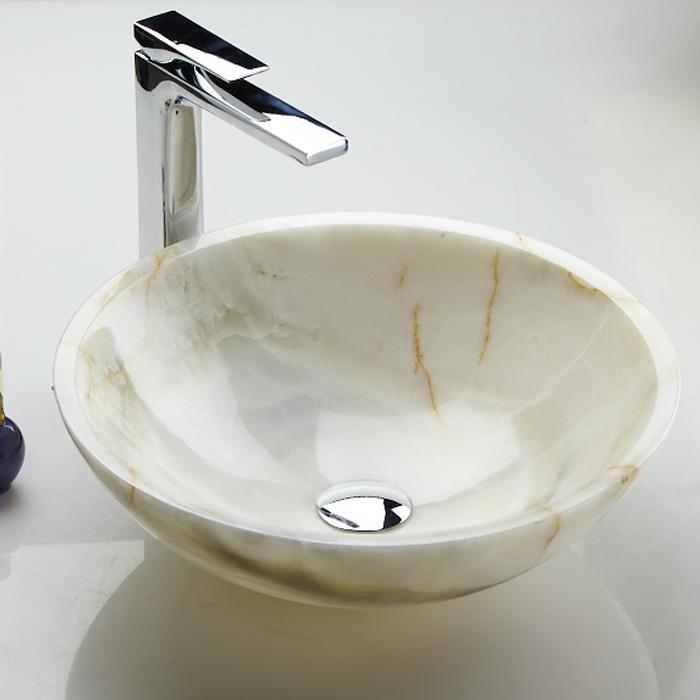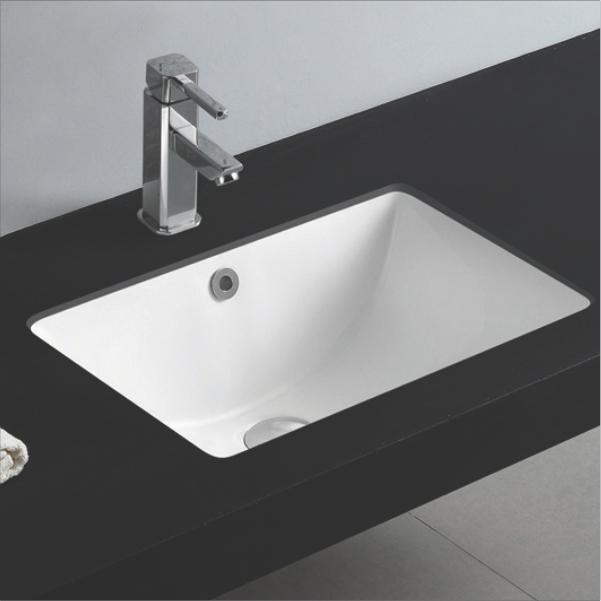The first image is the image on the left, the second image is the image on the right. Given the left and right images, does the statement "The drain hole is visible in only one image." hold true? Answer yes or no. No. The first image is the image on the left, the second image is the image on the right. For the images displayed, is the sentence "One image shows a rectangular, nonpedestal sink with an integrated flat counter." factually correct? Answer yes or no. Yes. The first image is the image on the left, the second image is the image on the right. Examine the images to the left and right. Is the description "One image shows a rectangular, nonpedestal sink with an integrated flat counter." accurate? Answer yes or no. Yes. 